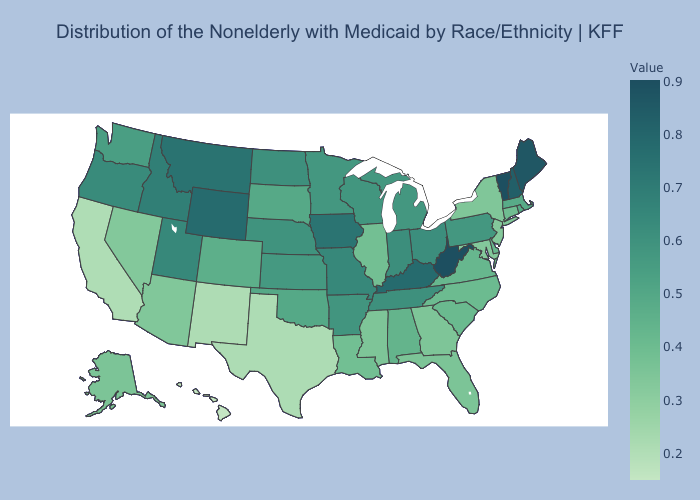Does Delaware have a higher value than Nevada?
Answer briefly. Yes. Which states have the highest value in the USA?
Give a very brief answer. Vermont. Among the states that border Kansas , which have the lowest value?
Concise answer only. Colorado. Among the states that border Montana , which have the highest value?
Keep it brief. Wyoming. Which states hav the highest value in the West?
Write a very short answer. Wyoming. Among the states that border Indiana , which have the highest value?
Be succinct. Kentucky. 